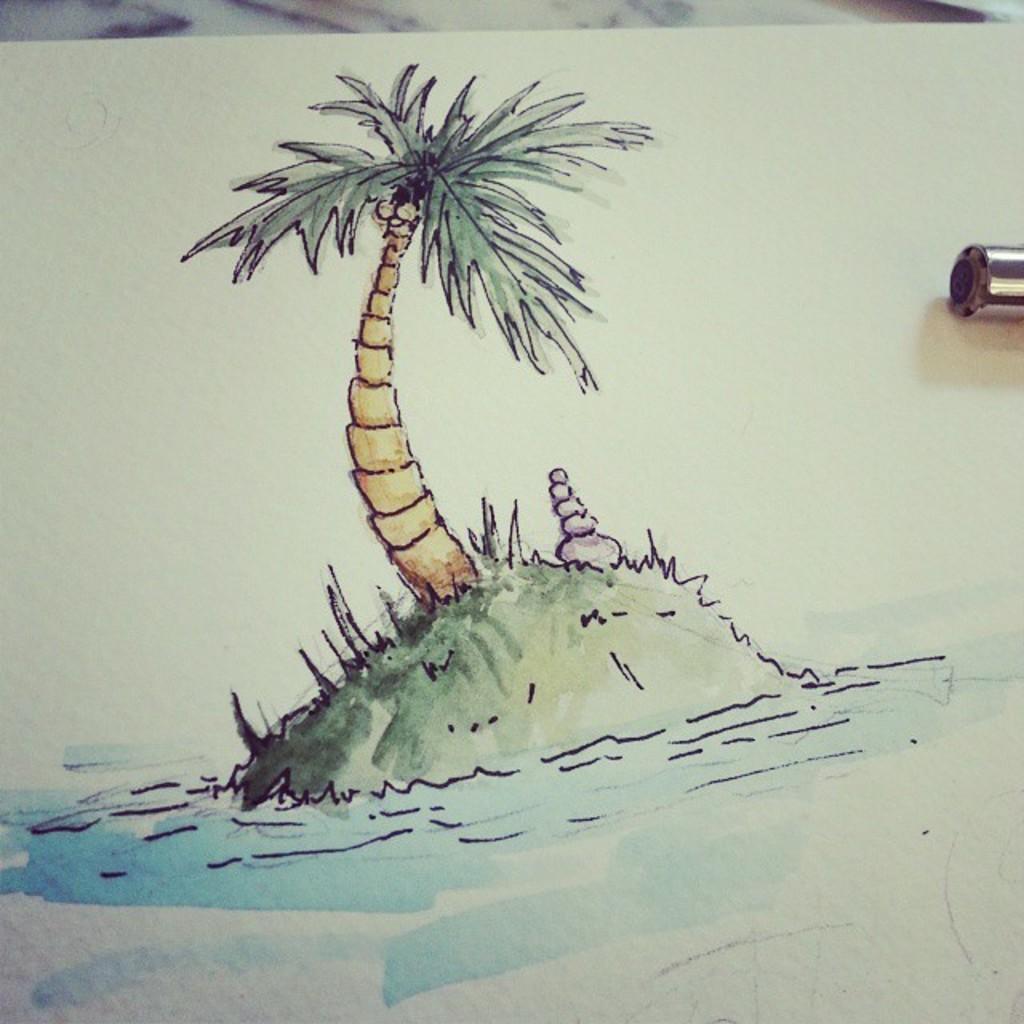In one or two sentences, can you explain what this image depicts? In this image there is an art. There is a painting of a tree in the middle. At the bottom there is water. 